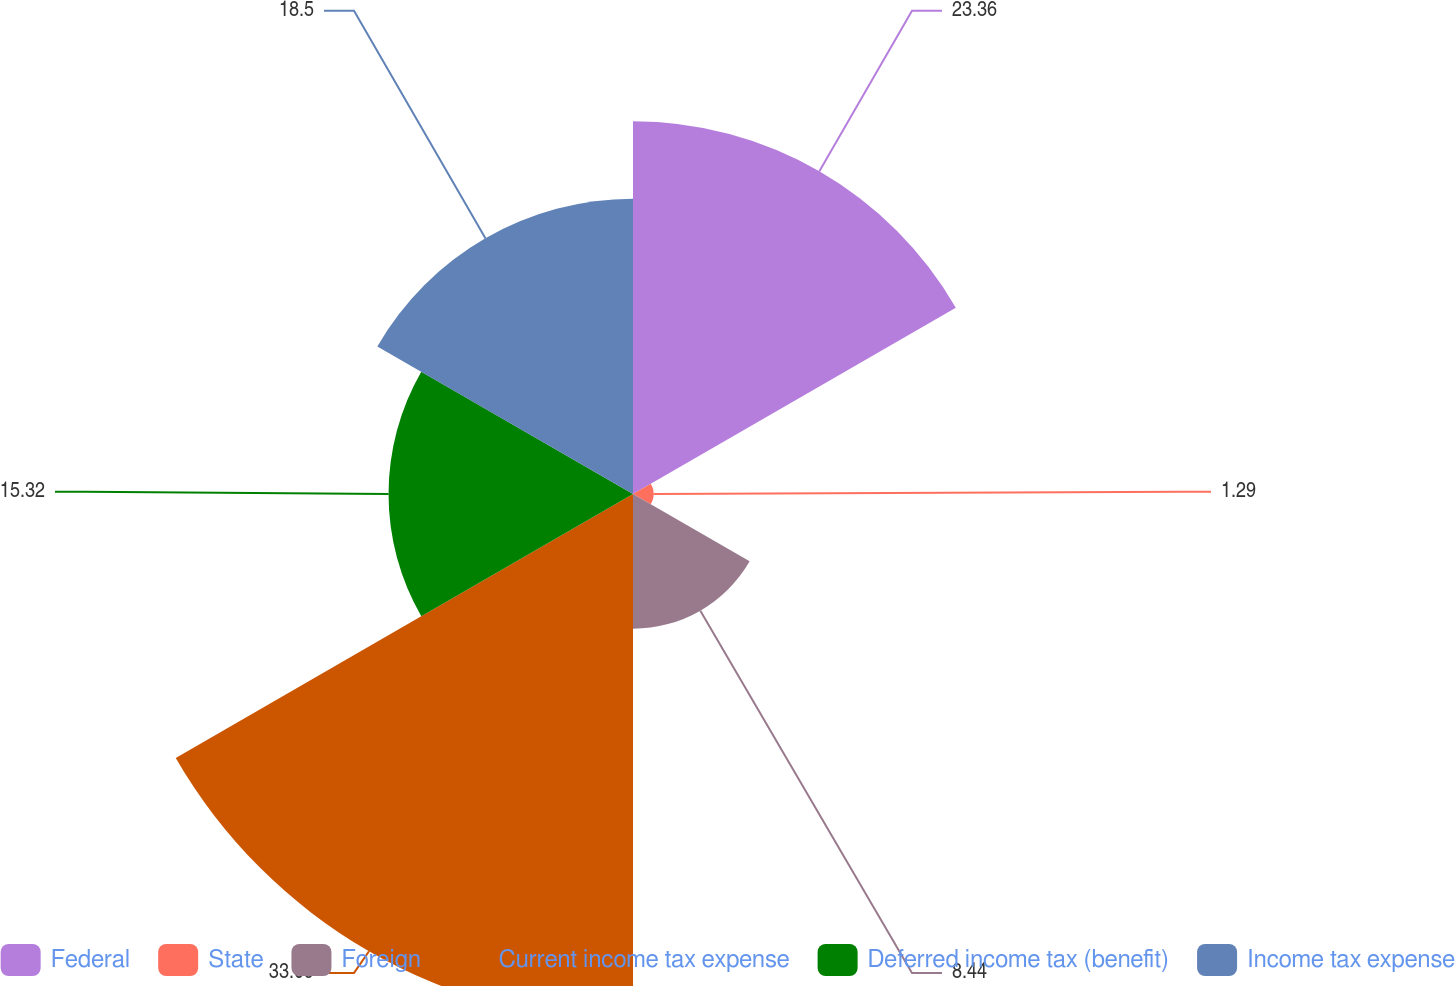Convert chart. <chart><loc_0><loc_0><loc_500><loc_500><pie_chart><fcel>Federal<fcel>State<fcel>Foreign<fcel>Current income tax expense<fcel>Deferred income tax (benefit)<fcel>Income tax expense<nl><fcel>23.36%<fcel>1.29%<fcel>8.44%<fcel>33.09%<fcel>15.32%<fcel>18.5%<nl></chart> 